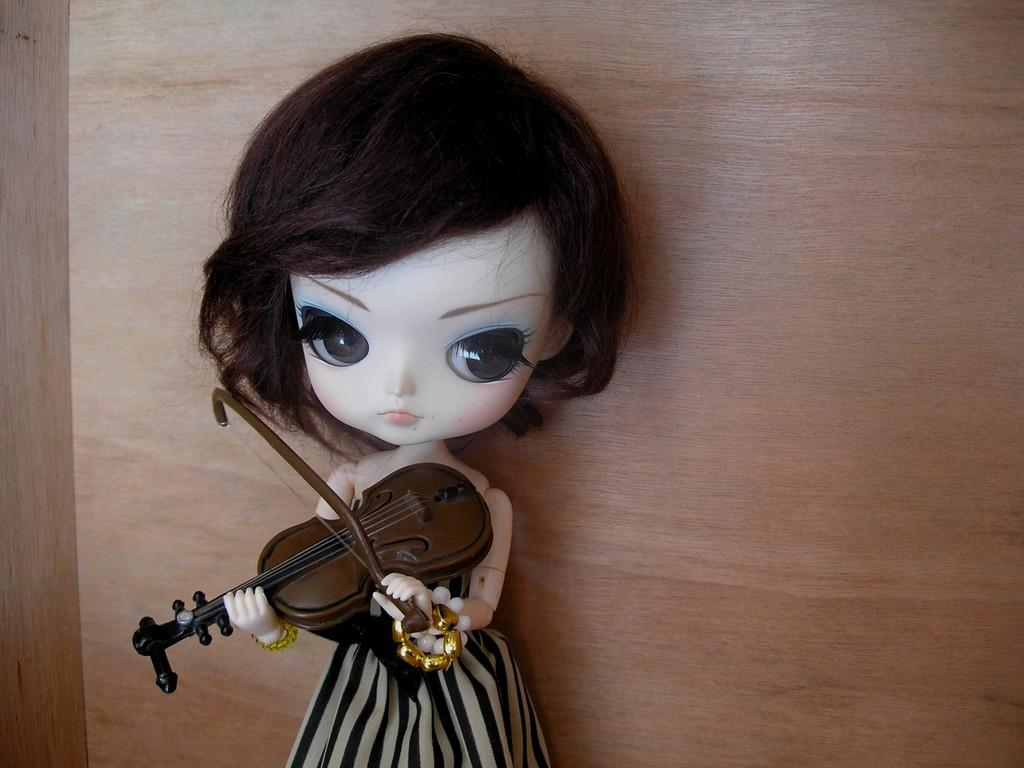What is the main subject of the image? There is a doll in the image. What is the doll holding in the image? The doll is holding a guitar. How many matches are visible in the image? There are no matches present in the image. What type of mark can be seen on the doll's face in the image? There is no mark visible on the doll's face in the image. 